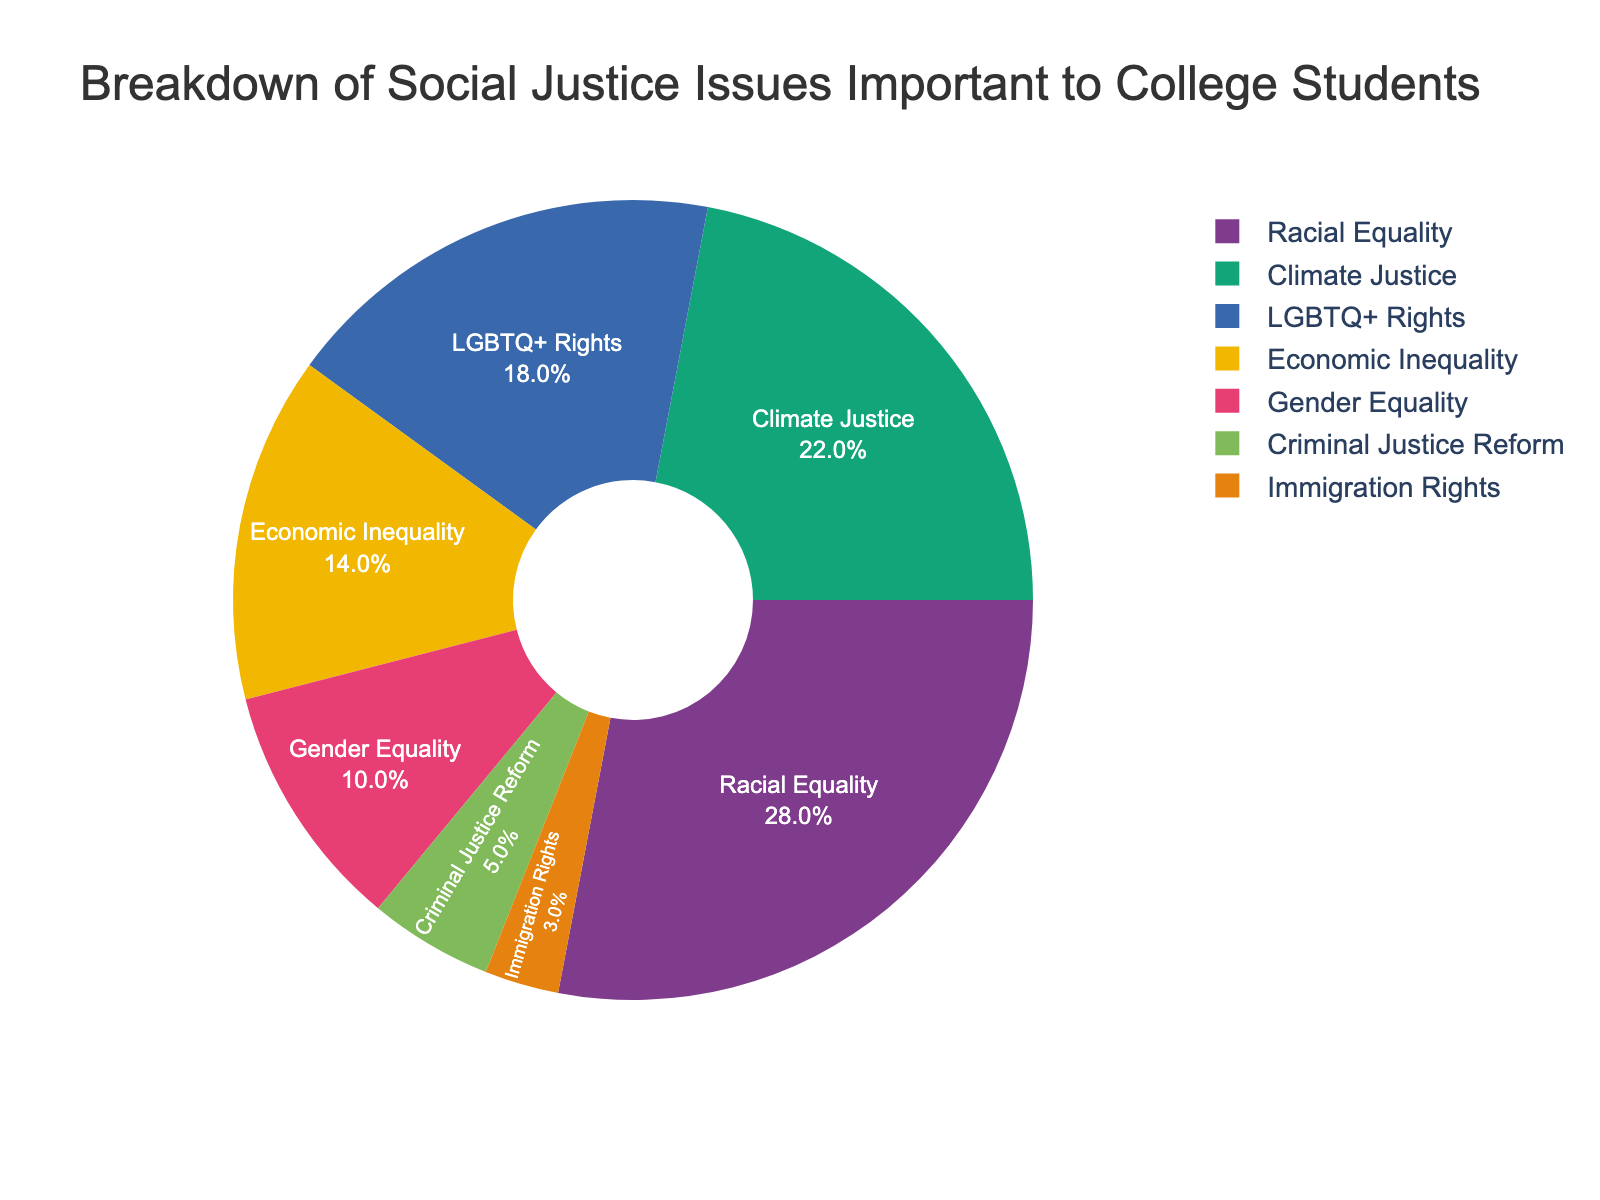Which social justice issue is the most important to college students? The pie chart shows different categories, and the category with the largest section represents the most important issue. The largest section belongs to Racial Equality.
Answer: Racial Equality Which social justice issue has the smallest percentage of importance to college students? The pie chart shows different categories, and the category with the smallest section represents the least important issue. The smallest section belongs to Immigration Rights.
Answer: Immigration Rights What is the total percentage for both Racial Equality and Climate Justice combined? To find the total percentage, add the percentages of Racial Equality and Climate Justice. Racial Equality is 28% and Climate Justice is 22%. So, 28% + 22% = 50%.
Answer: 50% Which two social justice issues have a combined importance percentage equal to or greater than Gender Equality? Gender Equality has 10%. Find two categories whose combined percentages are equal to or greater than 10%. LGBTQ+ Rights and Economic Inequality have 18% and 14%, respectively, which are individually greater than 10%.
Answer: LGBTQ+ Rights and Economic Inequality Which social justice issue is more important to college students: Economic Inequality or Gender Equality? Compare the percentages of the two categories. Economic Inequality is 14%, and Gender Equality is 10%. Since 14% is greater than 10%, Economic Inequality is more important.
Answer: Economic Inequality How much more important is Racial Equality than Criminal Justice Reform to college students? Subtract the percentage of Criminal Justice Reform from the percentage of Racial Equality. Racial Equality is 28%, and Criminal Justice Reform is 5%. So, 28% - 5% = 23%.
Answer: 23% What percentage of college students consider LGBTQ+ Rights and Criminal Justice Reform combined important? Add the percentages of LGBTQ+ Rights and Criminal Justice Reform. LGBTQ+ Rights is 18%, and Criminal Justice Reform is 5%. So, 18% + 5% = 23%.
Answer: 23% If we combine Climate Justice and Immigration Rights, what would their percentage be? Add the percentages of Climate Justice and Immigration Rights. Climate Justice is 22%, and Immigration Rights is 3%. So, 22% + 3% = 25%.
Answer: 25% Which social justice issue is less important: Climate Justice or Economic Inequality? Compare the percentages of the two categories. Climate Justice is 22%, and Economic Inequality is 14%. Since 14% is less than 22%, Economic Inequality is less important.
Answer: Economic Inequality 